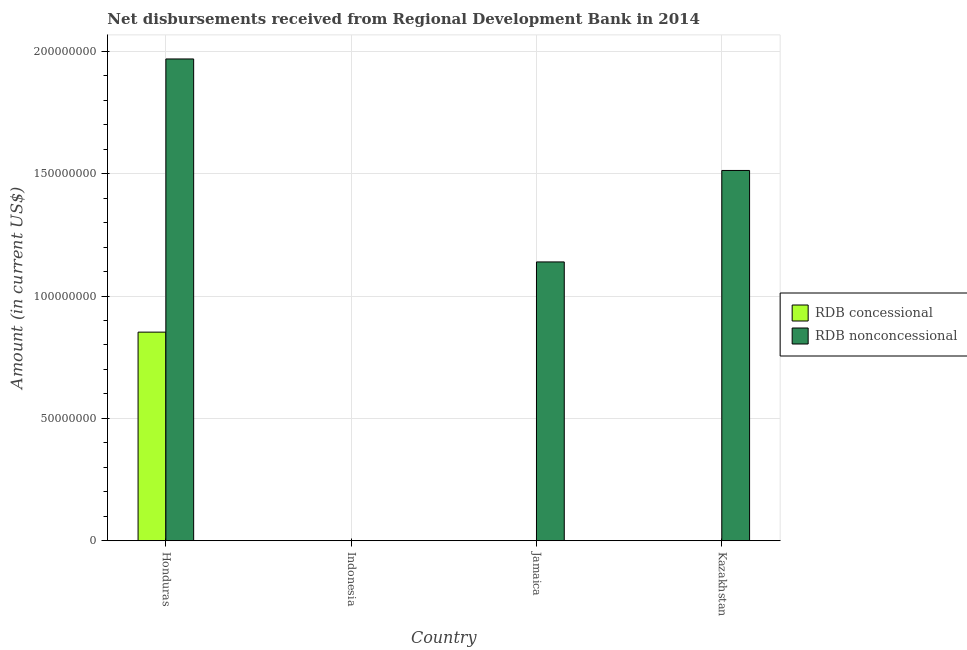How many different coloured bars are there?
Keep it short and to the point. 2. Are the number of bars on each tick of the X-axis equal?
Your answer should be compact. No. How many bars are there on the 2nd tick from the left?
Keep it short and to the point. 0. How many bars are there on the 1st tick from the right?
Make the answer very short. 1. What is the label of the 1st group of bars from the left?
Your answer should be compact. Honduras. What is the net concessional disbursements from rdb in Kazakhstan?
Ensure brevity in your answer.  0. Across all countries, what is the maximum net non concessional disbursements from rdb?
Make the answer very short. 1.97e+08. Across all countries, what is the minimum net non concessional disbursements from rdb?
Make the answer very short. 0. In which country was the net non concessional disbursements from rdb maximum?
Offer a terse response. Honduras. What is the total net non concessional disbursements from rdb in the graph?
Provide a succinct answer. 4.62e+08. What is the difference between the net non concessional disbursements from rdb in Honduras and that in Jamaica?
Give a very brief answer. 8.30e+07. What is the average net non concessional disbursements from rdb per country?
Your response must be concise. 1.16e+08. What is the difference between the net non concessional disbursements from rdb and net concessional disbursements from rdb in Honduras?
Offer a terse response. 1.12e+08. In how many countries, is the net non concessional disbursements from rdb greater than 30000000 US$?
Give a very brief answer. 3. What is the difference between the highest and the second highest net non concessional disbursements from rdb?
Make the answer very short. 4.56e+07. What is the difference between the highest and the lowest net non concessional disbursements from rdb?
Provide a short and direct response. 1.97e+08. In how many countries, is the net concessional disbursements from rdb greater than the average net concessional disbursements from rdb taken over all countries?
Offer a very short reply. 1. How many bars are there?
Your answer should be compact. 4. Are all the bars in the graph horizontal?
Make the answer very short. No. Does the graph contain any zero values?
Offer a very short reply. Yes. Does the graph contain grids?
Ensure brevity in your answer.  Yes. Where does the legend appear in the graph?
Make the answer very short. Center right. What is the title of the graph?
Offer a very short reply. Net disbursements received from Regional Development Bank in 2014. Does "Underweight" appear as one of the legend labels in the graph?
Keep it short and to the point. No. What is the label or title of the Y-axis?
Keep it short and to the point. Amount (in current US$). What is the Amount (in current US$) of RDB concessional in Honduras?
Provide a succinct answer. 8.53e+07. What is the Amount (in current US$) of RDB nonconcessional in Honduras?
Offer a terse response. 1.97e+08. What is the Amount (in current US$) of RDB concessional in Jamaica?
Provide a succinct answer. 0. What is the Amount (in current US$) in RDB nonconcessional in Jamaica?
Keep it short and to the point. 1.14e+08. What is the Amount (in current US$) of RDB concessional in Kazakhstan?
Offer a terse response. 0. What is the Amount (in current US$) of RDB nonconcessional in Kazakhstan?
Make the answer very short. 1.51e+08. Across all countries, what is the maximum Amount (in current US$) of RDB concessional?
Offer a terse response. 8.53e+07. Across all countries, what is the maximum Amount (in current US$) of RDB nonconcessional?
Provide a short and direct response. 1.97e+08. What is the total Amount (in current US$) in RDB concessional in the graph?
Give a very brief answer. 8.53e+07. What is the total Amount (in current US$) in RDB nonconcessional in the graph?
Provide a succinct answer. 4.62e+08. What is the difference between the Amount (in current US$) of RDB nonconcessional in Honduras and that in Jamaica?
Offer a terse response. 8.30e+07. What is the difference between the Amount (in current US$) in RDB nonconcessional in Honduras and that in Kazakhstan?
Provide a succinct answer. 4.56e+07. What is the difference between the Amount (in current US$) of RDB nonconcessional in Jamaica and that in Kazakhstan?
Offer a terse response. -3.74e+07. What is the difference between the Amount (in current US$) in RDB concessional in Honduras and the Amount (in current US$) in RDB nonconcessional in Jamaica?
Keep it short and to the point. -2.87e+07. What is the difference between the Amount (in current US$) in RDB concessional in Honduras and the Amount (in current US$) in RDB nonconcessional in Kazakhstan?
Ensure brevity in your answer.  -6.61e+07. What is the average Amount (in current US$) in RDB concessional per country?
Give a very brief answer. 2.13e+07. What is the average Amount (in current US$) of RDB nonconcessional per country?
Provide a succinct answer. 1.16e+08. What is the difference between the Amount (in current US$) in RDB concessional and Amount (in current US$) in RDB nonconcessional in Honduras?
Your answer should be compact. -1.12e+08. What is the ratio of the Amount (in current US$) of RDB nonconcessional in Honduras to that in Jamaica?
Give a very brief answer. 1.73. What is the ratio of the Amount (in current US$) of RDB nonconcessional in Honduras to that in Kazakhstan?
Ensure brevity in your answer.  1.3. What is the ratio of the Amount (in current US$) of RDB nonconcessional in Jamaica to that in Kazakhstan?
Your answer should be compact. 0.75. What is the difference between the highest and the second highest Amount (in current US$) in RDB nonconcessional?
Ensure brevity in your answer.  4.56e+07. What is the difference between the highest and the lowest Amount (in current US$) of RDB concessional?
Your answer should be very brief. 8.53e+07. What is the difference between the highest and the lowest Amount (in current US$) of RDB nonconcessional?
Keep it short and to the point. 1.97e+08. 